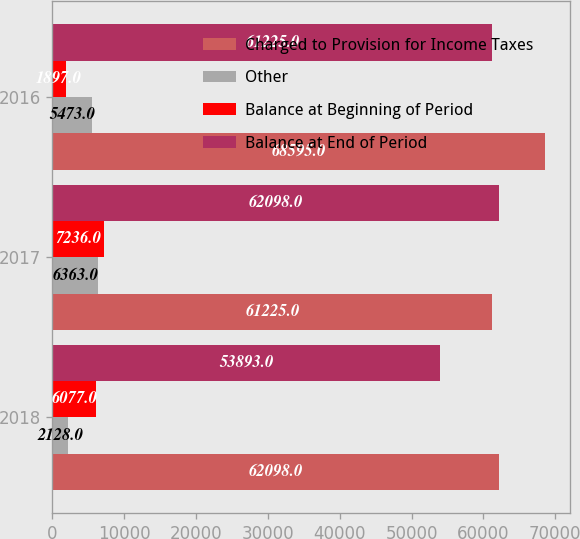<chart> <loc_0><loc_0><loc_500><loc_500><stacked_bar_chart><ecel><fcel>2018<fcel>2017<fcel>2016<nl><fcel>Charged to Provision for Income Taxes<fcel>62098<fcel>61225<fcel>68595<nl><fcel>Other<fcel>2128<fcel>6363<fcel>5473<nl><fcel>Balance at Beginning of Period<fcel>6077<fcel>7236<fcel>1897<nl><fcel>Balance at End of Period<fcel>53893<fcel>62098<fcel>61225<nl></chart> 